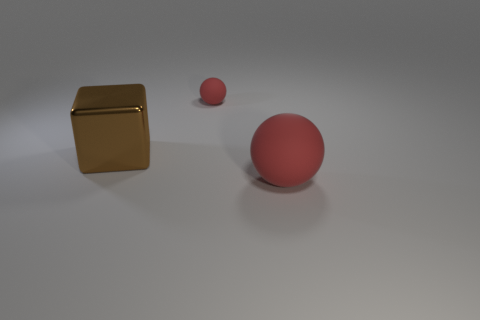What number of things are small green things or tiny rubber objects?
Ensure brevity in your answer.  1. Are there more large metal things right of the metal cube than things right of the large red ball?
Give a very brief answer. No. Does the thing that is behind the big brown block have the same color as the large thing behind the big red rubber thing?
Provide a short and direct response. No. There is a object behind the large metallic cube behind the large thing on the right side of the small red rubber ball; how big is it?
Your answer should be compact. Small. What color is the other matte object that is the same shape as the tiny matte thing?
Your answer should be compact. Red. Are there more small red rubber balls that are on the right side of the large red matte sphere than balls?
Your answer should be compact. No. Do the brown object and the big object that is on the right side of the tiny red object have the same shape?
Provide a succinct answer. No. Is there any other thing that is the same size as the brown metal block?
Offer a terse response. Yes. There is another red rubber thing that is the same shape as the tiny red object; what is its size?
Ensure brevity in your answer.  Large. Is the number of cyan blocks greater than the number of big blocks?
Offer a very short reply. No. 